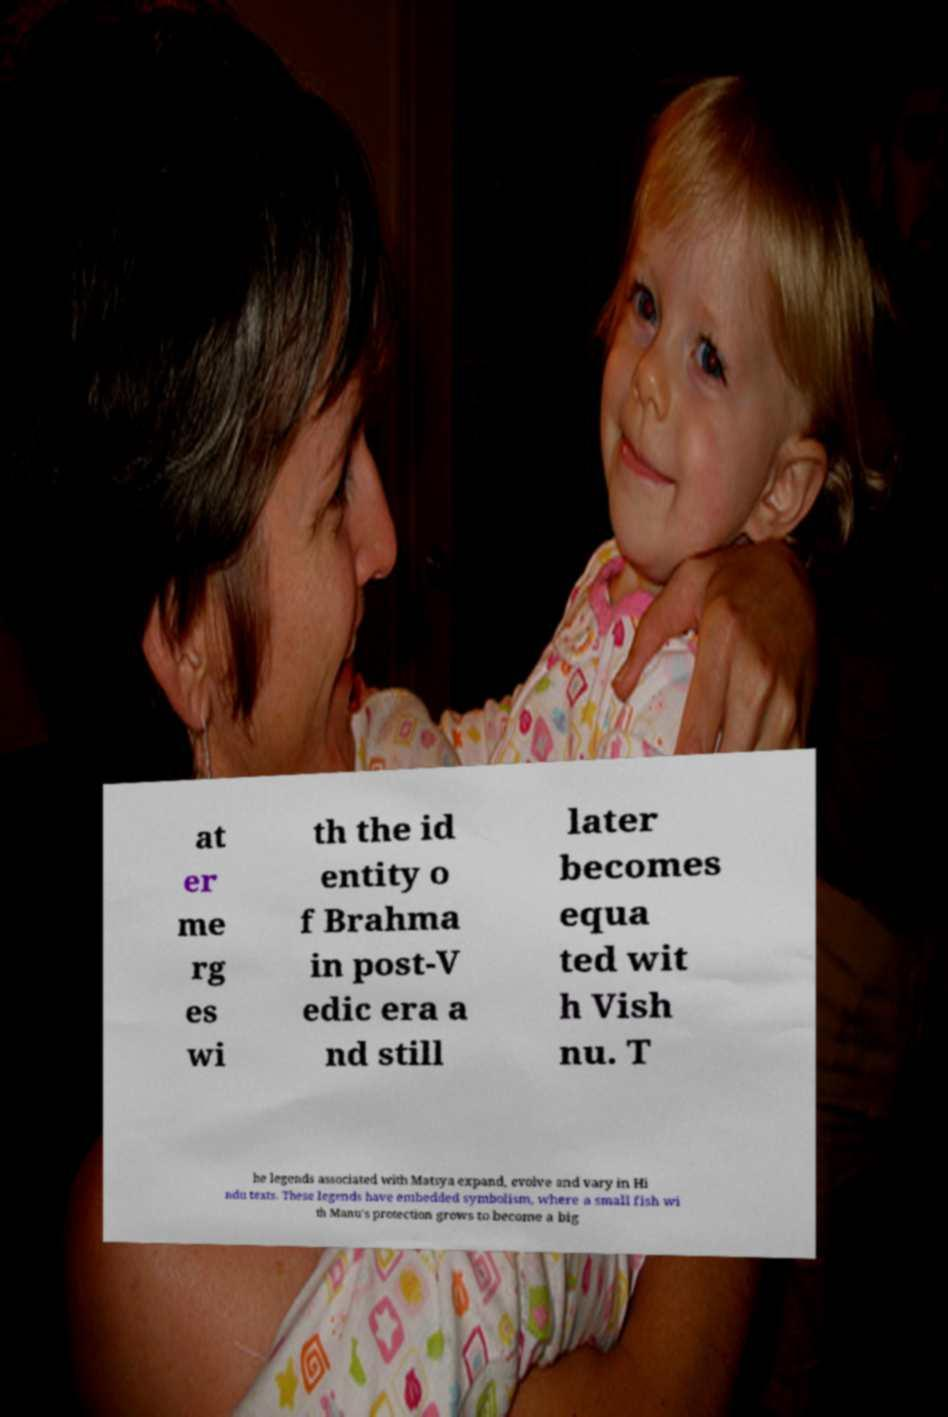Could you extract and type out the text from this image? at er me rg es wi th the id entity o f Brahma in post-V edic era a nd still later becomes equa ted wit h Vish nu. T he legends associated with Matsya expand, evolve and vary in Hi ndu texts. These legends have embedded symbolism, where a small fish wi th Manu's protection grows to become a big 